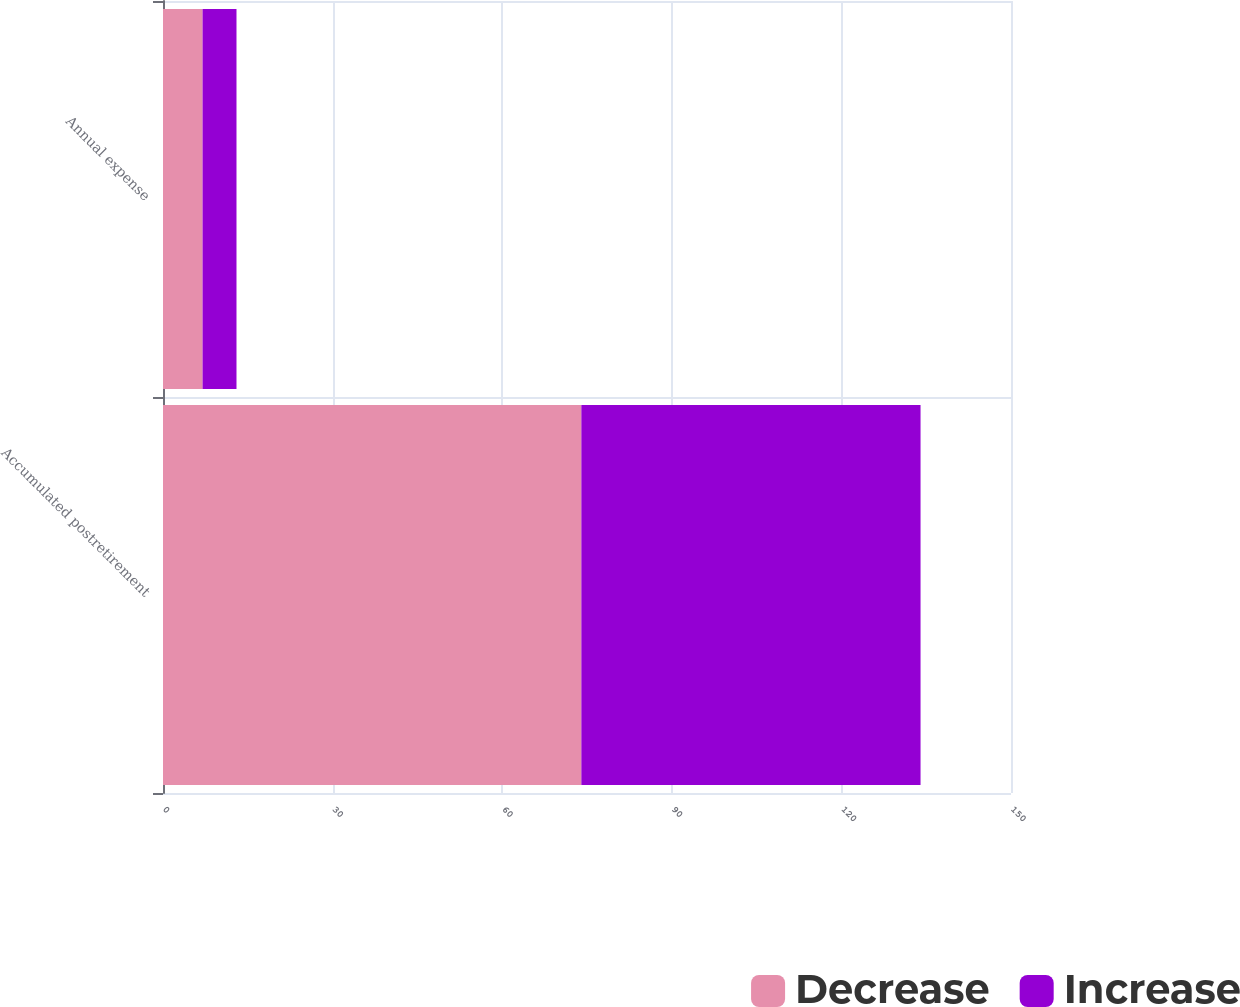Convert chart. <chart><loc_0><loc_0><loc_500><loc_500><stacked_bar_chart><ecel><fcel>Accumulated postretirement<fcel>Annual expense<nl><fcel>Decrease<fcel>74<fcel>7<nl><fcel>Increase<fcel>60<fcel>6<nl></chart> 